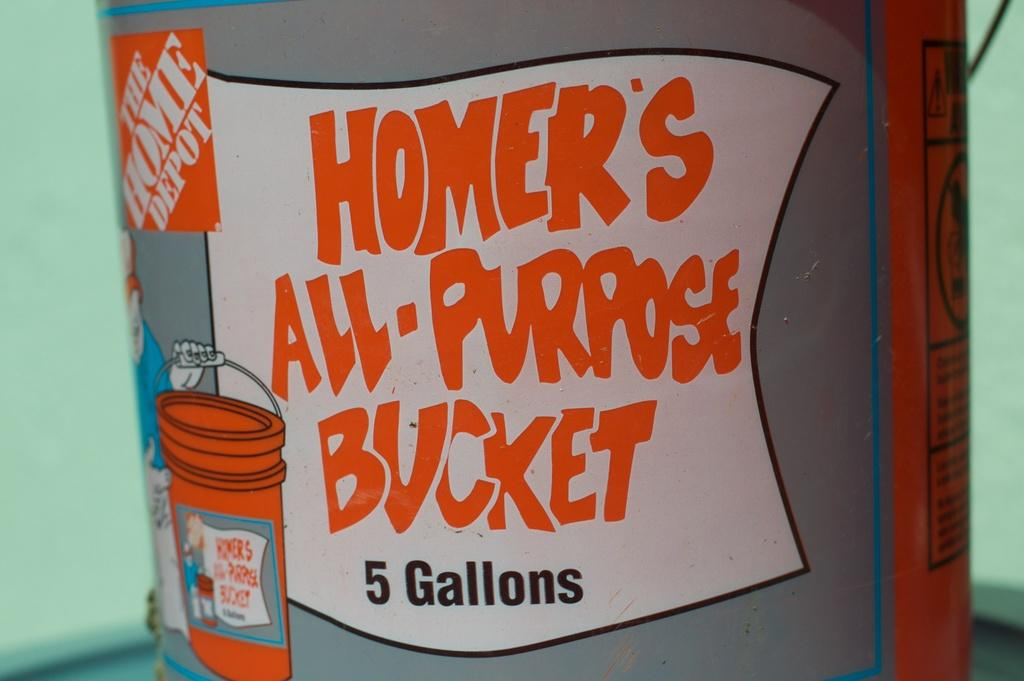<image>
Summarize the visual content of the image. A cartoon label covers a 5 gallon bucket. 